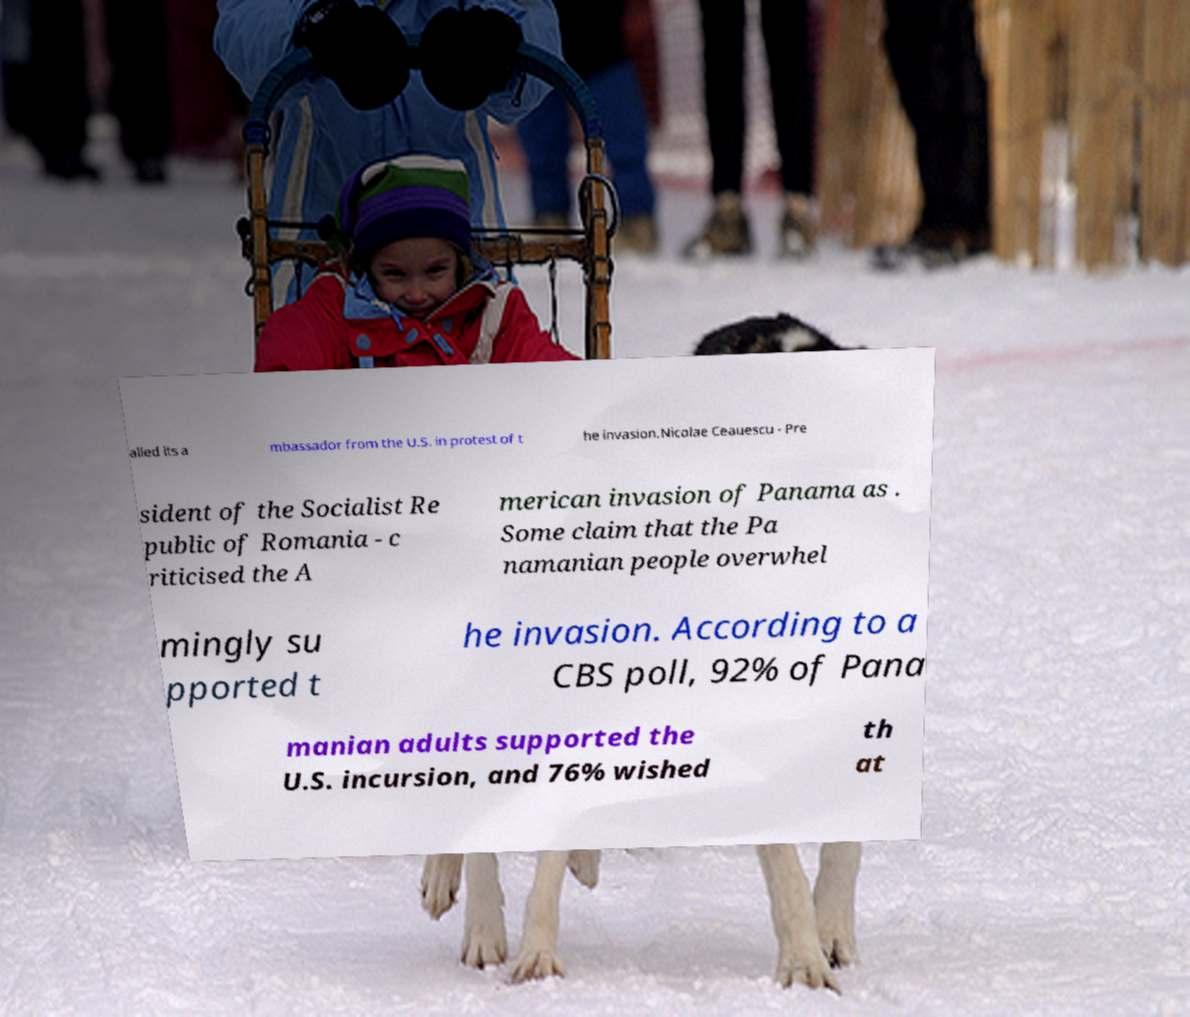Can you read and provide the text displayed in the image?This photo seems to have some interesting text. Can you extract and type it out for me? alled its a mbassador from the U.S. in protest of t he invasion.Nicolae Ceauescu - Pre sident of the Socialist Re public of Romania - c riticised the A merican invasion of Panama as . Some claim that the Pa namanian people overwhel mingly su pported t he invasion. According to a CBS poll, 92% of Pana manian adults supported the U.S. incursion, and 76% wished th at 